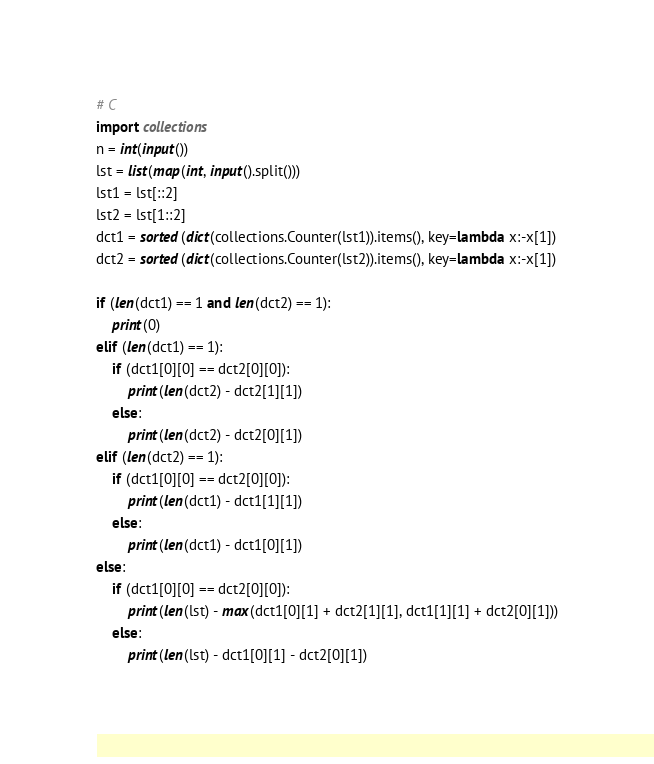Convert code to text. <code><loc_0><loc_0><loc_500><loc_500><_Python_># C
import collections
n = int(input())
lst = list(map(int, input().split()))
lst1 = lst[::2]
lst2 = lst[1::2]
dct1 = sorted(dict(collections.Counter(lst1)).items(), key=lambda x:-x[1])
dct2 = sorted(dict(collections.Counter(lst2)).items(), key=lambda x:-x[1])

if (len(dct1) == 1 and len(dct2) == 1):
	print(0)
elif (len(dct1) == 1):
	if (dct1[0][0] == dct2[0][0]):
		print(len(dct2) - dct2[1][1])
	else:
		print(len(dct2) - dct2[0][1])
elif (len(dct2) == 1):
	if (dct1[0][0] == dct2[0][0]):
		print(len(dct1) - dct1[1][1])
	else:
		print(len(dct1) - dct1[0][1])
else:
	if (dct1[0][0] == dct2[0][0]):
		print(len(lst) - max(dct1[0][1] + dct2[1][1], dct1[1][1] + dct2[0][1]))
	else:
		print(len(lst) - dct1[0][1] - dct2[0][1])
</code> 